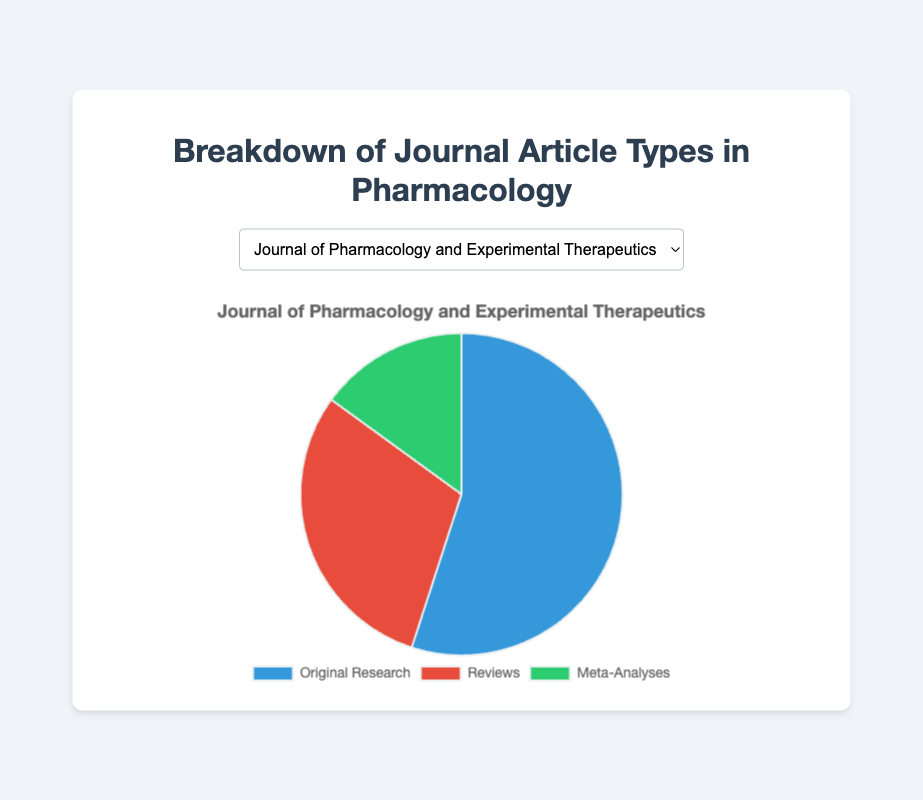What proportion of articles are original research in the Journal of Pharmacology and Experimental Therapeutics? To find the proportion, divide the number of original research articles by the total number of articles in the journal. This is 55/(55+30+15). Simplifying gives 55/100 = 0.55 or 55%
Answer: 55% Which journal has the highest number of meta-analyses articles, and how many are there? By comparing the number of meta-analyses articles across all journals: 15 in Journal of Pharmacology and Experimental Therapeutics, 15 in European Journal of Pharmacology, 15 in Pharmacological Reviews, 10 in British Journal of Pharmacology, and 10 in Pharmacology & Therapeutics. We see that the first three journals each have 15 meta-analyses articles, which is the highest value
Answer: Journal of Pharmacology and Experimental Therapeutics, European Journal of Pharmacology, Pharmacological Reviews; 15 What is the total number of review articles in all journals combined? Sum the number of review articles across all the journals: 30 in Journal of Pharmacology and Experimental Therapeutics + 25 in European Journal of Pharmacology + 45 in Pharmacological Reviews + 20 in British Journal of Pharmacology + 25 in Pharmacology & Therapeutics = 145
Answer: 145 Which type of article appears least frequently in the British Journal of Pharmacology? By examining the British Journal of Pharmacology, we see the breakdown is 70 (original research), 20 (reviews), and 10 (meta-analyses). The least frequent is meta-analyses with 10 articles
Answer: Meta-analyses How many more original research articles are there in Pharmacology & Therapeutics compared to the Pharmacological Reviews? Subtract the number of original research articles in Pharmacological Reviews from the number in Pharmacology & Therapeutics: 65 (Pharmacology & Therapeutics) - 40 (Pharmacological Reviews) = 25
Answer: 25 If we combine the review articles and meta-analyses from the European Journal of Pharmacology, what proportion do they form of the total articles in that journal? First, find the combined number of review articles and meta-analyses: 25 + 15 = 40. Then, divide by the total number of articles: 40/(60 + 25 + 15) = 40/100 = 0.4 or 40%
Answer: 40% Which journal has the highest proportion of review articles, and what is the proportion? Calculate the proportion of review articles for each journal. For example, for Pharmacological Reviews, it’s 45/(40+45+15)=45/100=0.45 or 45%. Repeat for each journal to find that Pharmacological Reviews has the highest proportion of reviews at 45%
Answer: Pharmacological Reviews, 45% What is the average number of original research articles across all journals? To find the average, sum the number of original research articles and divide by the number of journals: (55+60+40+70+65)/5=290/5=58
Answer: 58 